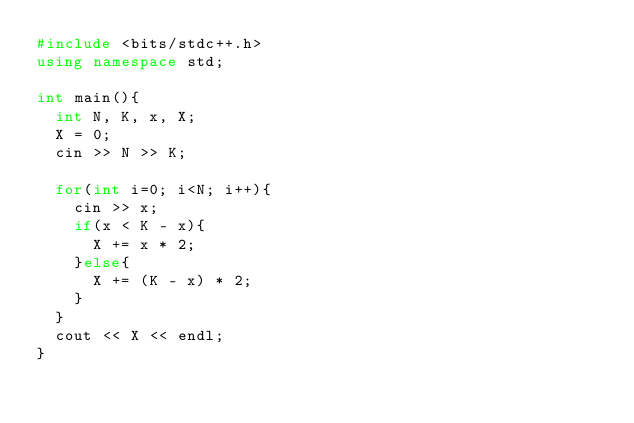<code> <loc_0><loc_0><loc_500><loc_500><_C++_>#include <bits/stdc++.h>
using namespace std;

int main(){
  int N, K, x, X;
  X = 0;
  cin >> N >> K;
  
  for(int i=0; i<N; i++){
    cin >> x;
    if(x < K - x){
      X += x * 2;
    }else{
      X += (K - x) * 2;
    }
  }
  cout << X << endl;
}</code> 